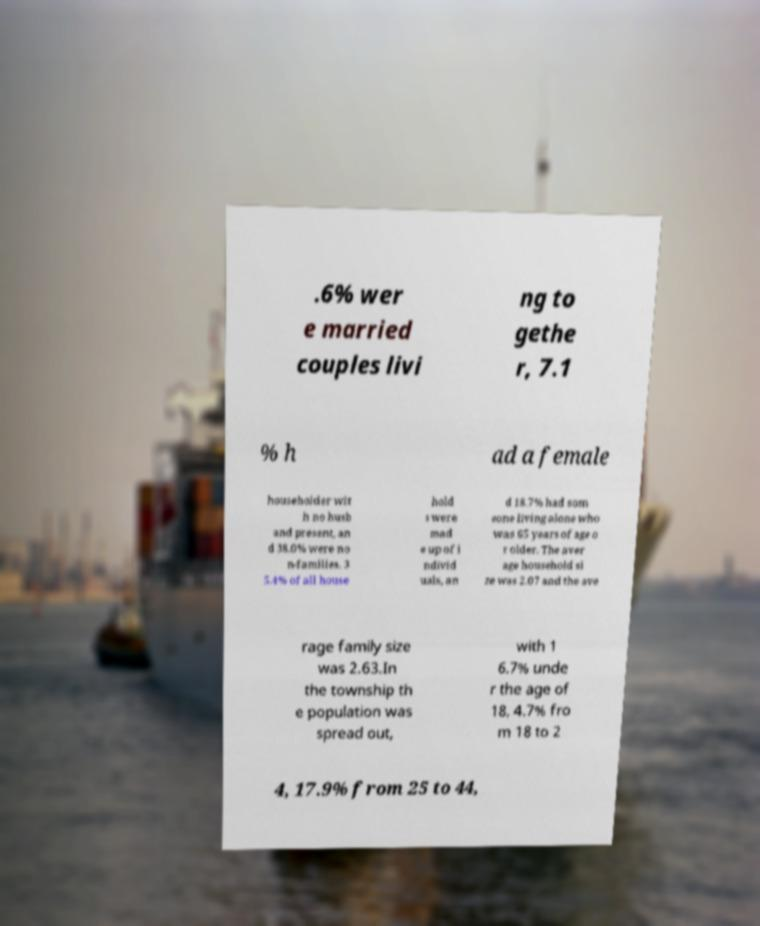What messages or text are displayed in this image? I need them in a readable, typed format. .6% wer e married couples livi ng to gethe r, 7.1 % h ad a female householder wit h no husb and present, an d 38.0% were no n-families. 3 5.4% of all house hold s were mad e up of i ndivid uals, an d 18.7% had som eone living alone who was 65 years of age o r older. The aver age household si ze was 2.07 and the ave rage family size was 2.63.In the township th e population was spread out, with 1 6.7% unde r the age of 18, 4.7% fro m 18 to 2 4, 17.9% from 25 to 44, 